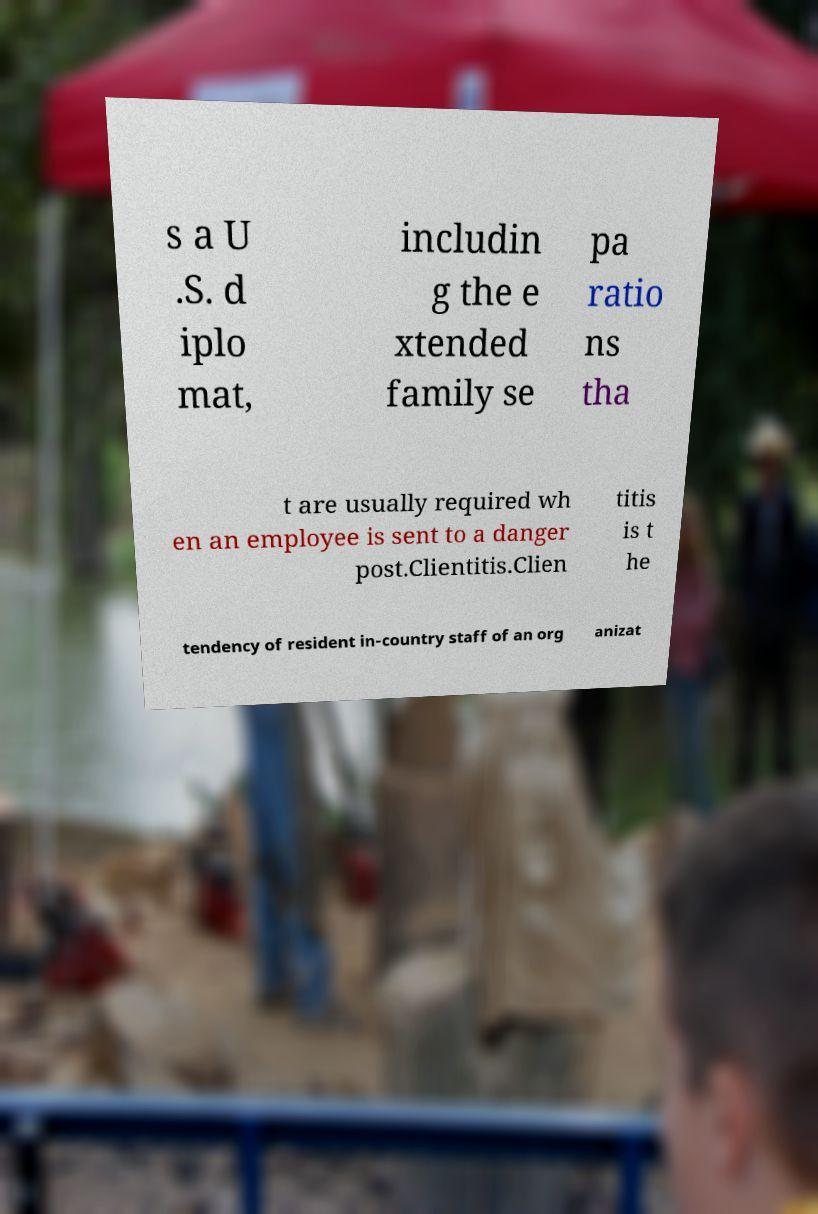Can you read and provide the text displayed in the image?This photo seems to have some interesting text. Can you extract and type it out for me? s a U .S. d iplo mat, includin g the e xtended family se pa ratio ns tha t are usually required wh en an employee is sent to a danger post.Clientitis.Clien titis is t he tendency of resident in-country staff of an org anizat 